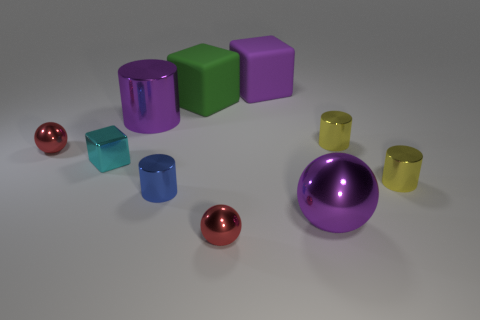How many red spheres must be subtracted to get 1 red spheres? 1 Subtract all cylinders. How many objects are left? 6 Add 3 cyan matte spheres. How many cyan matte spheres exist? 3 Subtract 0 brown cylinders. How many objects are left? 10 Subtract all matte cubes. Subtract all blue metallic objects. How many objects are left? 7 Add 5 big purple spheres. How many big purple spheres are left? 6 